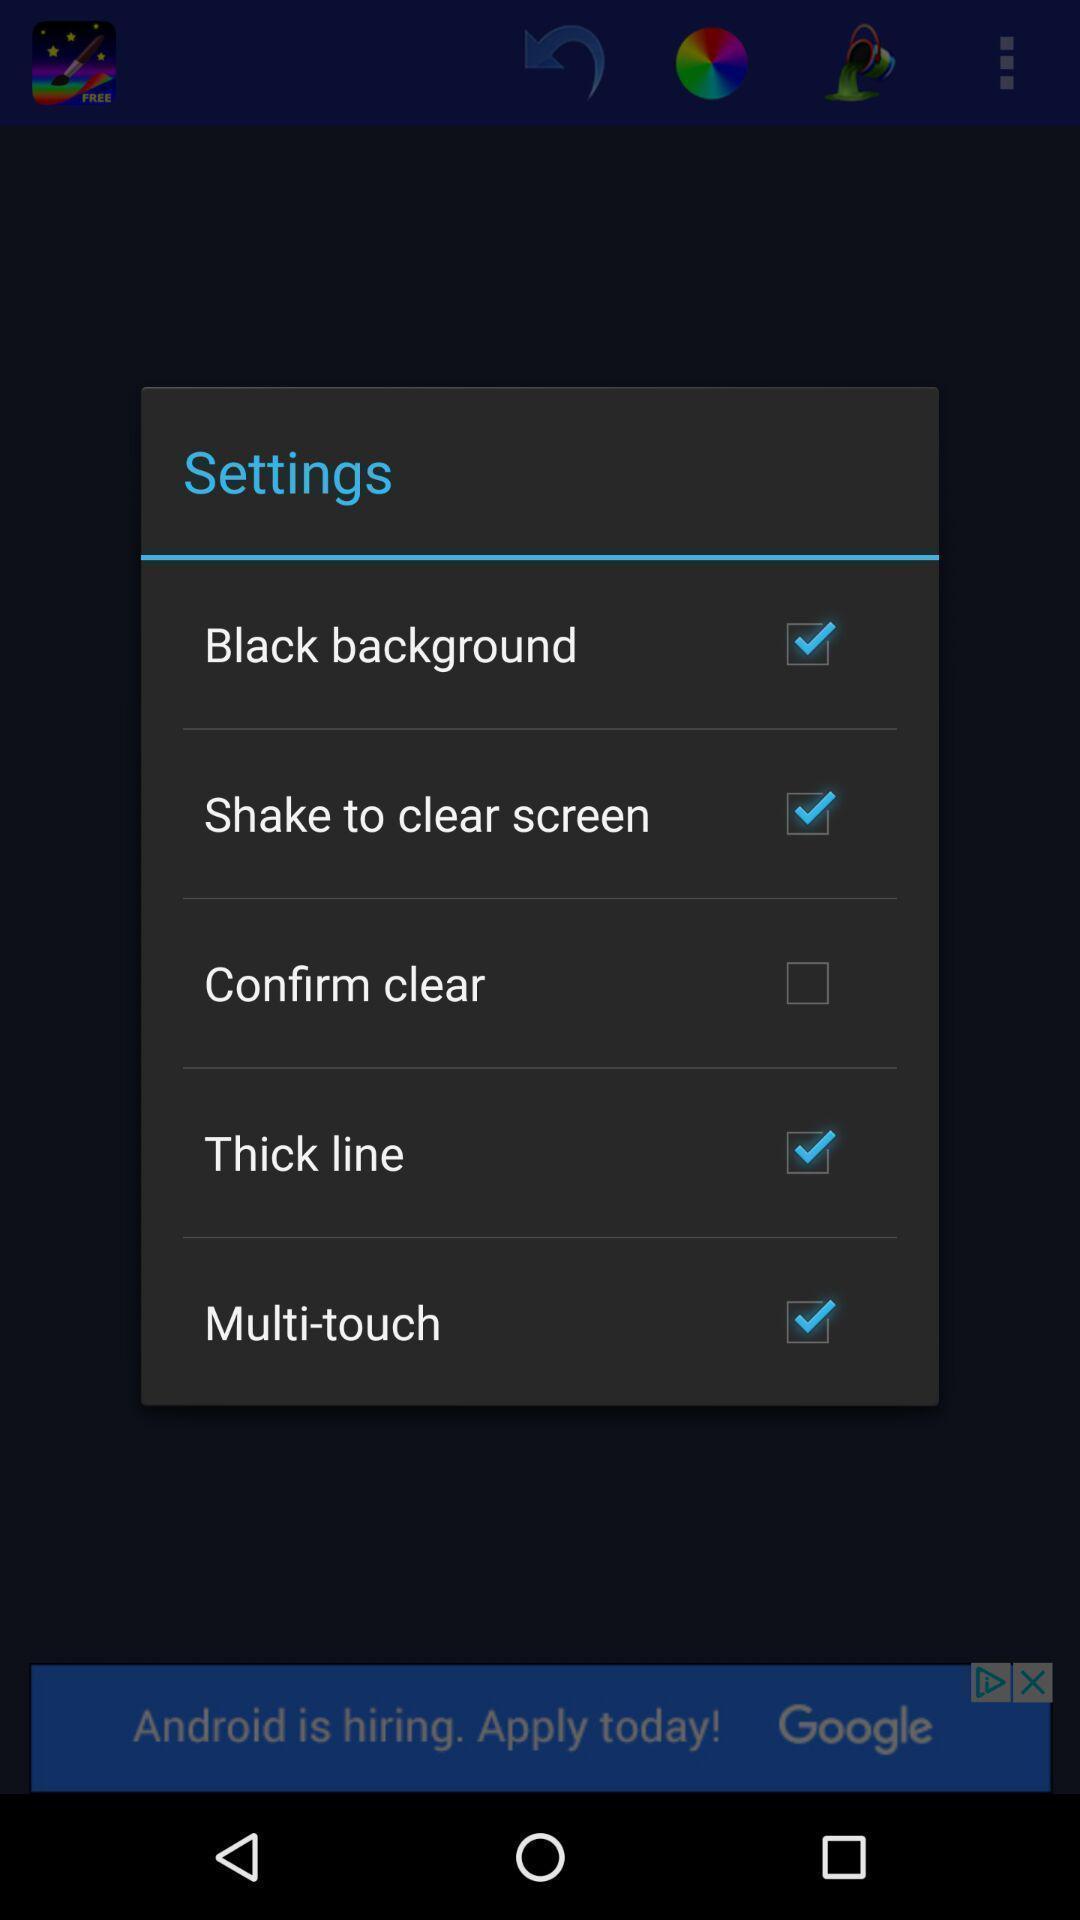Explain the elements present in this screenshot. Pop-up showing checkboxes to enable various settings. 